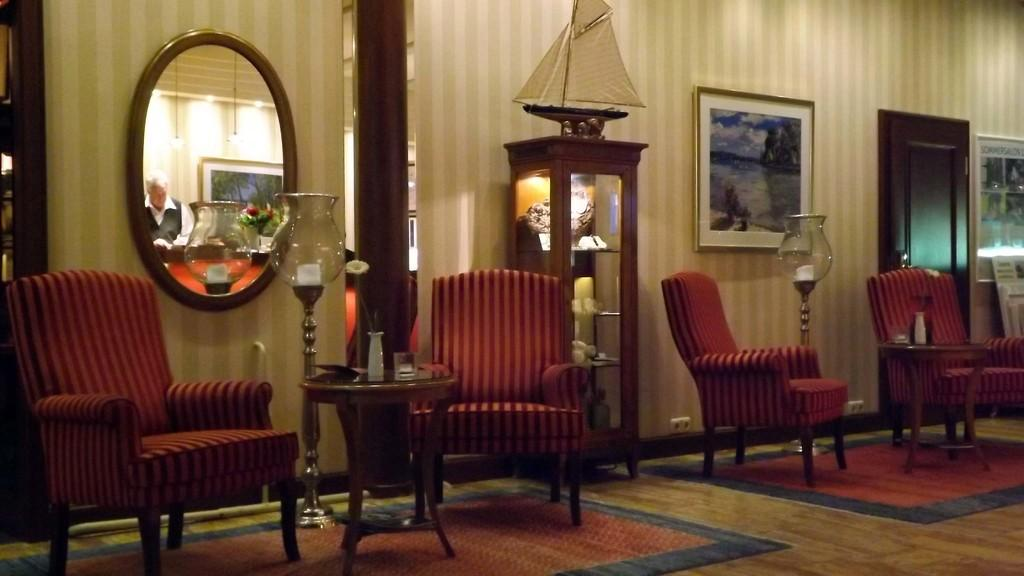What object is located on the wall in the left side of the image? There is a mirror on the wall in the left side of the image. What type of furniture can be seen in the image? There are chairs in the image. What is the purpose of the heart in the image? There is no heart present in the image, so it is not possible to determine its purpose. 